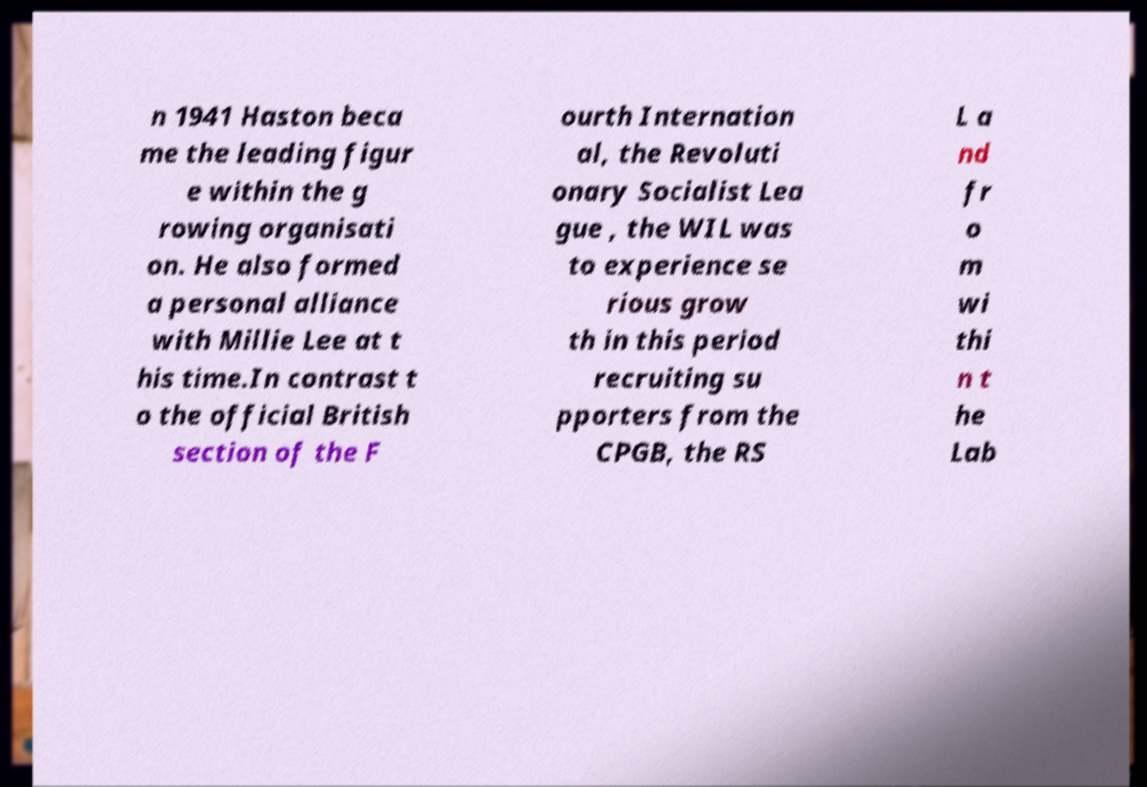There's text embedded in this image that I need extracted. Can you transcribe it verbatim? n 1941 Haston beca me the leading figur e within the g rowing organisati on. He also formed a personal alliance with Millie Lee at t his time.In contrast t o the official British section of the F ourth Internation al, the Revoluti onary Socialist Lea gue , the WIL was to experience se rious grow th in this period recruiting su pporters from the CPGB, the RS L a nd fr o m wi thi n t he Lab 